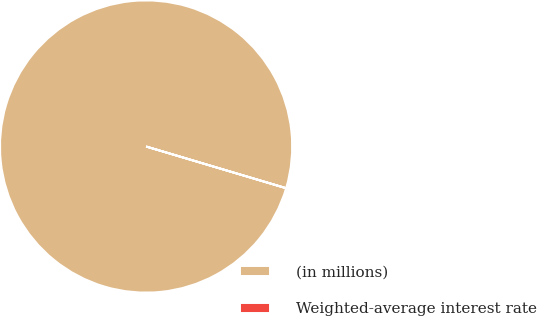Convert chart. <chart><loc_0><loc_0><loc_500><loc_500><pie_chart><fcel>(in millions)<fcel>Weighted-average interest rate<nl><fcel>99.98%<fcel>0.02%<nl></chart> 